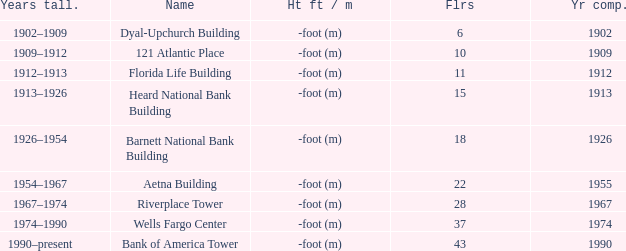How tall is the florida life building, completed before 1990? -foot (m). 